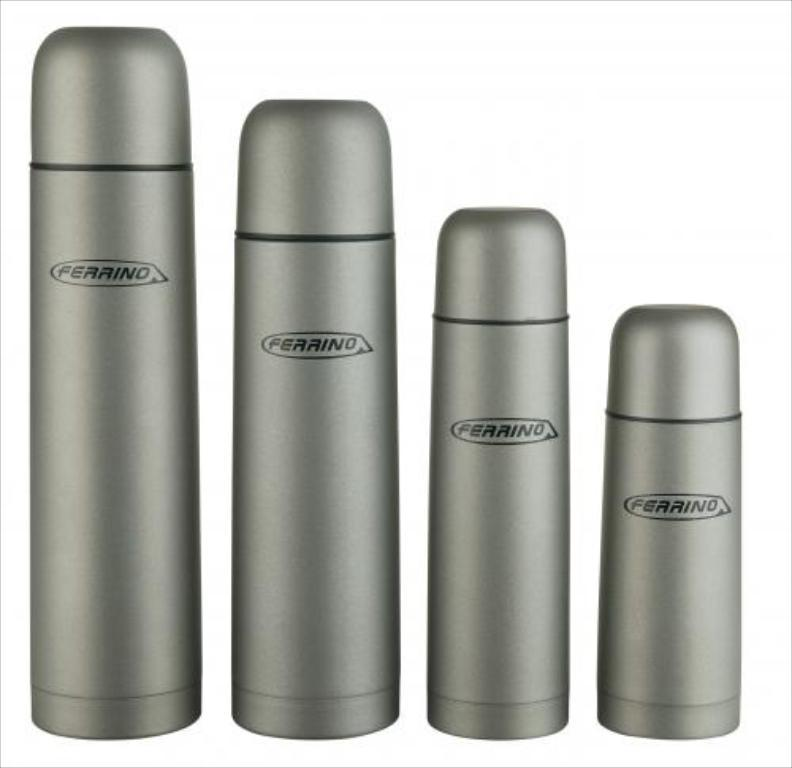<image>
Summarize the visual content of the image. A graduated set of stainless steel thermos bottles with the name Ferrino on them. 